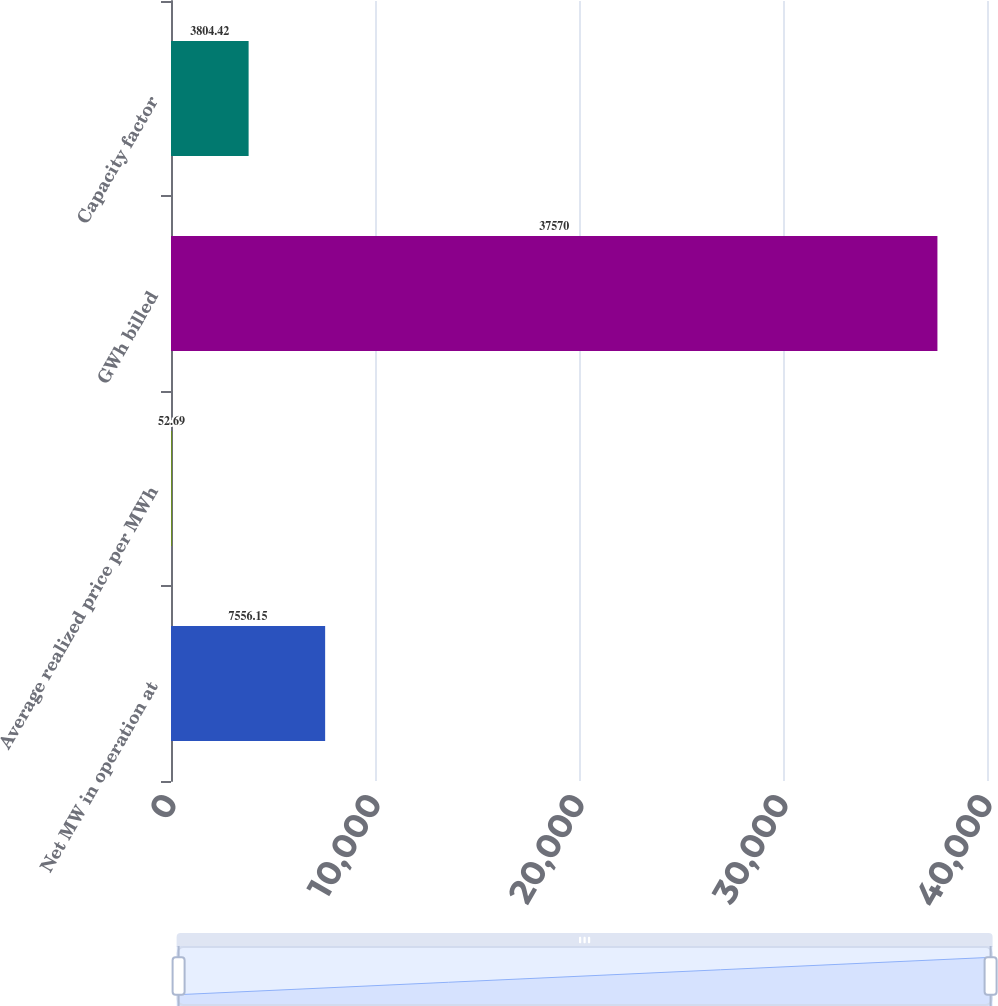Convert chart. <chart><loc_0><loc_0><loc_500><loc_500><bar_chart><fcel>Net MW in operation at<fcel>Average realized price per MWh<fcel>GWh billed<fcel>Capacity factor<nl><fcel>7556.15<fcel>52.69<fcel>37570<fcel>3804.42<nl></chart> 